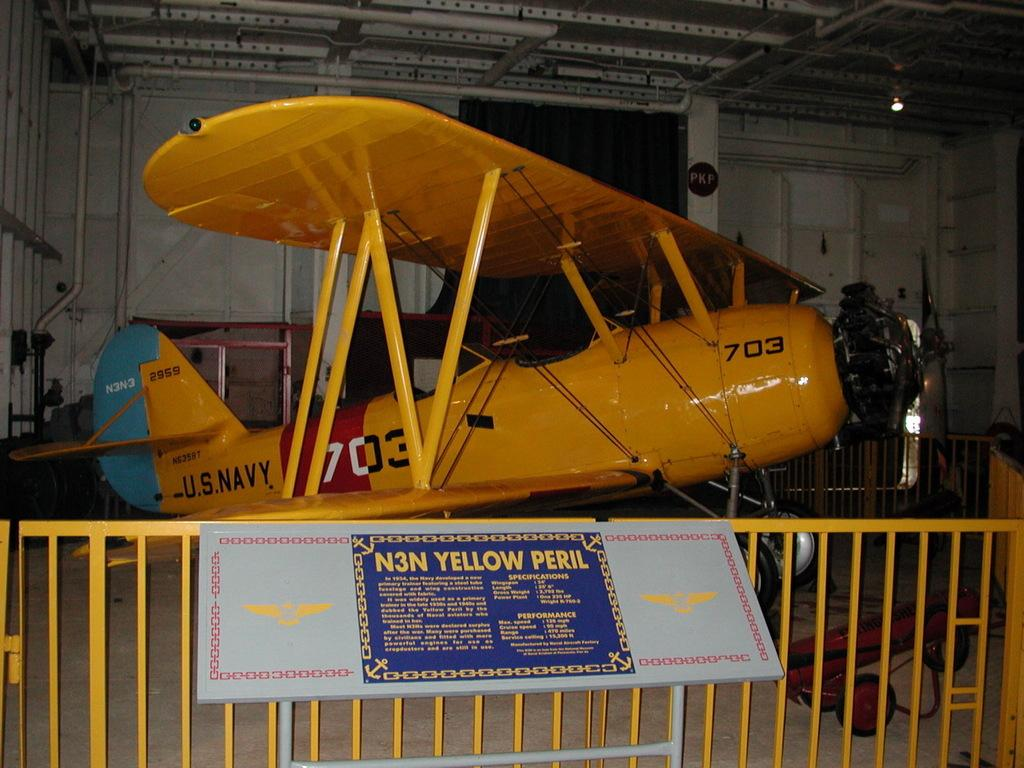<image>
Give a short and clear explanation of the subsequent image. An exhibition of a yellow U.S. Navy air plane with a sign that reads N3N Yellow Peril. 